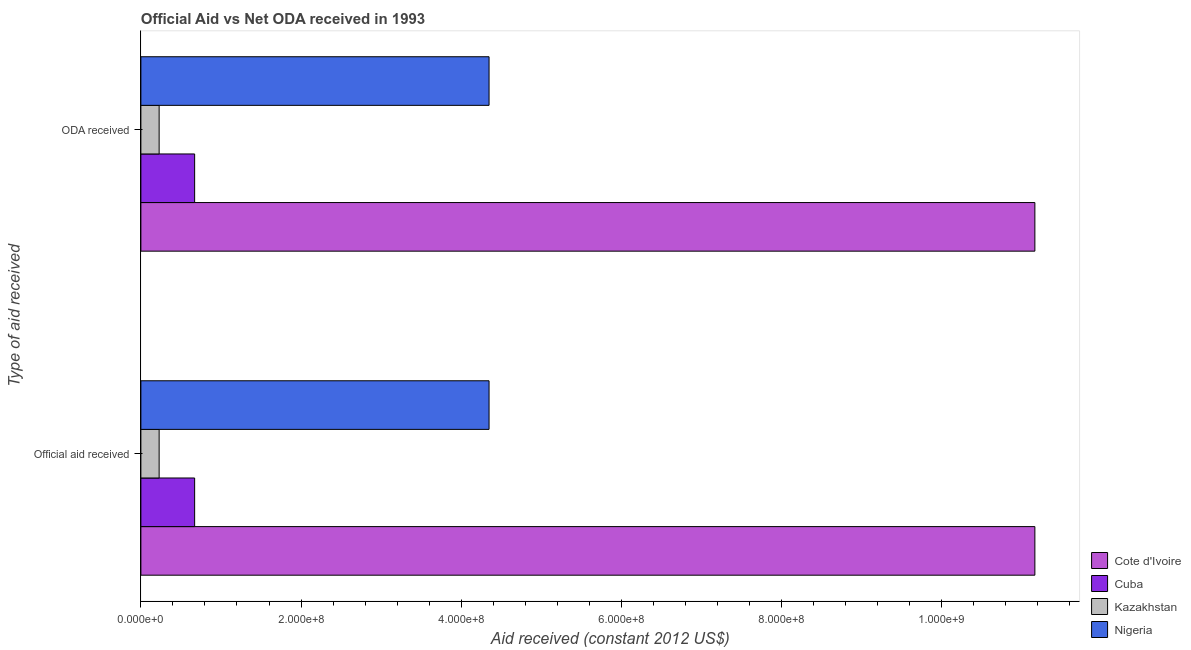How many different coloured bars are there?
Make the answer very short. 4. How many groups of bars are there?
Provide a succinct answer. 2. Are the number of bars on each tick of the Y-axis equal?
Keep it short and to the point. Yes. What is the label of the 1st group of bars from the top?
Your answer should be very brief. ODA received. What is the official aid received in Kazakhstan?
Offer a terse response. 2.28e+07. Across all countries, what is the maximum official aid received?
Your answer should be compact. 1.12e+09. Across all countries, what is the minimum oda received?
Your answer should be compact. 2.28e+07. In which country was the official aid received maximum?
Give a very brief answer. Cote d'Ivoire. In which country was the oda received minimum?
Make the answer very short. Kazakhstan. What is the total oda received in the graph?
Your response must be concise. 1.64e+09. What is the difference between the oda received in Nigeria and that in Kazakhstan?
Keep it short and to the point. 4.12e+08. What is the difference between the official aid received in Kazakhstan and the oda received in Cote d'Ivoire?
Your response must be concise. -1.09e+09. What is the average official aid received per country?
Provide a succinct answer. 4.10e+08. What is the ratio of the oda received in Nigeria to that in Kazakhstan?
Provide a succinct answer. 19.08. Is the oda received in Cote d'Ivoire less than that in Kazakhstan?
Provide a succinct answer. No. What does the 1st bar from the top in ODA received represents?
Keep it short and to the point. Nigeria. What does the 4th bar from the bottom in Official aid received represents?
Your response must be concise. Nigeria. Are all the bars in the graph horizontal?
Make the answer very short. Yes. Does the graph contain grids?
Give a very brief answer. No. Where does the legend appear in the graph?
Offer a terse response. Bottom right. How are the legend labels stacked?
Offer a very short reply. Vertical. What is the title of the graph?
Provide a short and direct response. Official Aid vs Net ODA received in 1993 . Does "Gambia, The" appear as one of the legend labels in the graph?
Offer a very short reply. No. What is the label or title of the X-axis?
Give a very brief answer. Aid received (constant 2012 US$). What is the label or title of the Y-axis?
Provide a short and direct response. Type of aid received. What is the Aid received (constant 2012 US$) of Cote d'Ivoire in Official aid received?
Your response must be concise. 1.12e+09. What is the Aid received (constant 2012 US$) of Cuba in Official aid received?
Your answer should be compact. 6.71e+07. What is the Aid received (constant 2012 US$) in Kazakhstan in Official aid received?
Ensure brevity in your answer.  2.28e+07. What is the Aid received (constant 2012 US$) in Nigeria in Official aid received?
Ensure brevity in your answer.  4.35e+08. What is the Aid received (constant 2012 US$) of Cote d'Ivoire in ODA received?
Your answer should be compact. 1.12e+09. What is the Aid received (constant 2012 US$) in Cuba in ODA received?
Your answer should be compact. 6.71e+07. What is the Aid received (constant 2012 US$) of Kazakhstan in ODA received?
Make the answer very short. 2.28e+07. What is the Aid received (constant 2012 US$) in Nigeria in ODA received?
Offer a terse response. 4.35e+08. Across all Type of aid received, what is the maximum Aid received (constant 2012 US$) of Cote d'Ivoire?
Provide a short and direct response. 1.12e+09. Across all Type of aid received, what is the maximum Aid received (constant 2012 US$) of Cuba?
Keep it short and to the point. 6.71e+07. Across all Type of aid received, what is the maximum Aid received (constant 2012 US$) of Kazakhstan?
Offer a very short reply. 2.28e+07. Across all Type of aid received, what is the maximum Aid received (constant 2012 US$) in Nigeria?
Provide a short and direct response. 4.35e+08. Across all Type of aid received, what is the minimum Aid received (constant 2012 US$) of Cote d'Ivoire?
Offer a very short reply. 1.12e+09. Across all Type of aid received, what is the minimum Aid received (constant 2012 US$) in Cuba?
Your answer should be compact. 6.71e+07. Across all Type of aid received, what is the minimum Aid received (constant 2012 US$) in Kazakhstan?
Offer a terse response. 2.28e+07. Across all Type of aid received, what is the minimum Aid received (constant 2012 US$) in Nigeria?
Your answer should be very brief. 4.35e+08. What is the total Aid received (constant 2012 US$) of Cote d'Ivoire in the graph?
Ensure brevity in your answer.  2.23e+09. What is the total Aid received (constant 2012 US$) of Cuba in the graph?
Provide a short and direct response. 1.34e+08. What is the total Aid received (constant 2012 US$) in Kazakhstan in the graph?
Your response must be concise. 4.56e+07. What is the total Aid received (constant 2012 US$) in Nigeria in the graph?
Offer a very short reply. 8.70e+08. What is the difference between the Aid received (constant 2012 US$) of Cote d'Ivoire in Official aid received and that in ODA received?
Provide a succinct answer. 0. What is the difference between the Aid received (constant 2012 US$) of Cote d'Ivoire in Official aid received and the Aid received (constant 2012 US$) of Cuba in ODA received?
Provide a short and direct response. 1.05e+09. What is the difference between the Aid received (constant 2012 US$) of Cote d'Ivoire in Official aid received and the Aid received (constant 2012 US$) of Kazakhstan in ODA received?
Provide a succinct answer. 1.09e+09. What is the difference between the Aid received (constant 2012 US$) of Cote d'Ivoire in Official aid received and the Aid received (constant 2012 US$) of Nigeria in ODA received?
Your response must be concise. 6.82e+08. What is the difference between the Aid received (constant 2012 US$) of Cuba in Official aid received and the Aid received (constant 2012 US$) of Kazakhstan in ODA received?
Give a very brief answer. 4.43e+07. What is the difference between the Aid received (constant 2012 US$) in Cuba in Official aid received and the Aid received (constant 2012 US$) in Nigeria in ODA received?
Your answer should be very brief. -3.68e+08. What is the difference between the Aid received (constant 2012 US$) in Kazakhstan in Official aid received and the Aid received (constant 2012 US$) in Nigeria in ODA received?
Offer a terse response. -4.12e+08. What is the average Aid received (constant 2012 US$) in Cote d'Ivoire per Type of aid received?
Ensure brevity in your answer.  1.12e+09. What is the average Aid received (constant 2012 US$) in Cuba per Type of aid received?
Your response must be concise. 6.71e+07. What is the average Aid received (constant 2012 US$) in Kazakhstan per Type of aid received?
Provide a short and direct response. 2.28e+07. What is the average Aid received (constant 2012 US$) of Nigeria per Type of aid received?
Provide a short and direct response. 4.35e+08. What is the difference between the Aid received (constant 2012 US$) of Cote d'Ivoire and Aid received (constant 2012 US$) of Cuba in Official aid received?
Offer a terse response. 1.05e+09. What is the difference between the Aid received (constant 2012 US$) of Cote d'Ivoire and Aid received (constant 2012 US$) of Kazakhstan in Official aid received?
Your answer should be compact. 1.09e+09. What is the difference between the Aid received (constant 2012 US$) of Cote d'Ivoire and Aid received (constant 2012 US$) of Nigeria in Official aid received?
Your answer should be compact. 6.82e+08. What is the difference between the Aid received (constant 2012 US$) of Cuba and Aid received (constant 2012 US$) of Kazakhstan in Official aid received?
Your answer should be very brief. 4.43e+07. What is the difference between the Aid received (constant 2012 US$) of Cuba and Aid received (constant 2012 US$) of Nigeria in Official aid received?
Provide a short and direct response. -3.68e+08. What is the difference between the Aid received (constant 2012 US$) of Kazakhstan and Aid received (constant 2012 US$) of Nigeria in Official aid received?
Make the answer very short. -4.12e+08. What is the difference between the Aid received (constant 2012 US$) in Cote d'Ivoire and Aid received (constant 2012 US$) in Cuba in ODA received?
Your answer should be very brief. 1.05e+09. What is the difference between the Aid received (constant 2012 US$) of Cote d'Ivoire and Aid received (constant 2012 US$) of Kazakhstan in ODA received?
Provide a short and direct response. 1.09e+09. What is the difference between the Aid received (constant 2012 US$) of Cote d'Ivoire and Aid received (constant 2012 US$) of Nigeria in ODA received?
Offer a very short reply. 6.82e+08. What is the difference between the Aid received (constant 2012 US$) of Cuba and Aid received (constant 2012 US$) of Kazakhstan in ODA received?
Your response must be concise. 4.43e+07. What is the difference between the Aid received (constant 2012 US$) in Cuba and Aid received (constant 2012 US$) in Nigeria in ODA received?
Offer a terse response. -3.68e+08. What is the difference between the Aid received (constant 2012 US$) in Kazakhstan and Aid received (constant 2012 US$) in Nigeria in ODA received?
Ensure brevity in your answer.  -4.12e+08. What is the ratio of the Aid received (constant 2012 US$) of Cote d'Ivoire in Official aid received to that in ODA received?
Your response must be concise. 1. What is the ratio of the Aid received (constant 2012 US$) in Cuba in Official aid received to that in ODA received?
Your answer should be compact. 1. What is the ratio of the Aid received (constant 2012 US$) of Kazakhstan in Official aid received to that in ODA received?
Offer a very short reply. 1. What is the ratio of the Aid received (constant 2012 US$) in Nigeria in Official aid received to that in ODA received?
Give a very brief answer. 1. What is the difference between the highest and the second highest Aid received (constant 2012 US$) of Cote d'Ivoire?
Provide a succinct answer. 0. What is the difference between the highest and the second highest Aid received (constant 2012 US$) in Cuba?
Your answer should be very brief. 0. What is the difference between the highest and the second highest Aid received (constant 2012 US$) of Nigeria?
Provide a succinct answer. 0. What is the difference between the highest and the lowest Aid received (constant 2012 US$) of Cote d'Ivoire?
Give a very brief answer. 0. What is the difference between the highest and the lowest Aid received (constant 2012 US$) in Kazakhstan?
Your answer should be very brief. 0. What is the difference between the highest and the lowest Aid received (constant 2012 US$) of Nigeria?
Your answer should be compact. 0. 